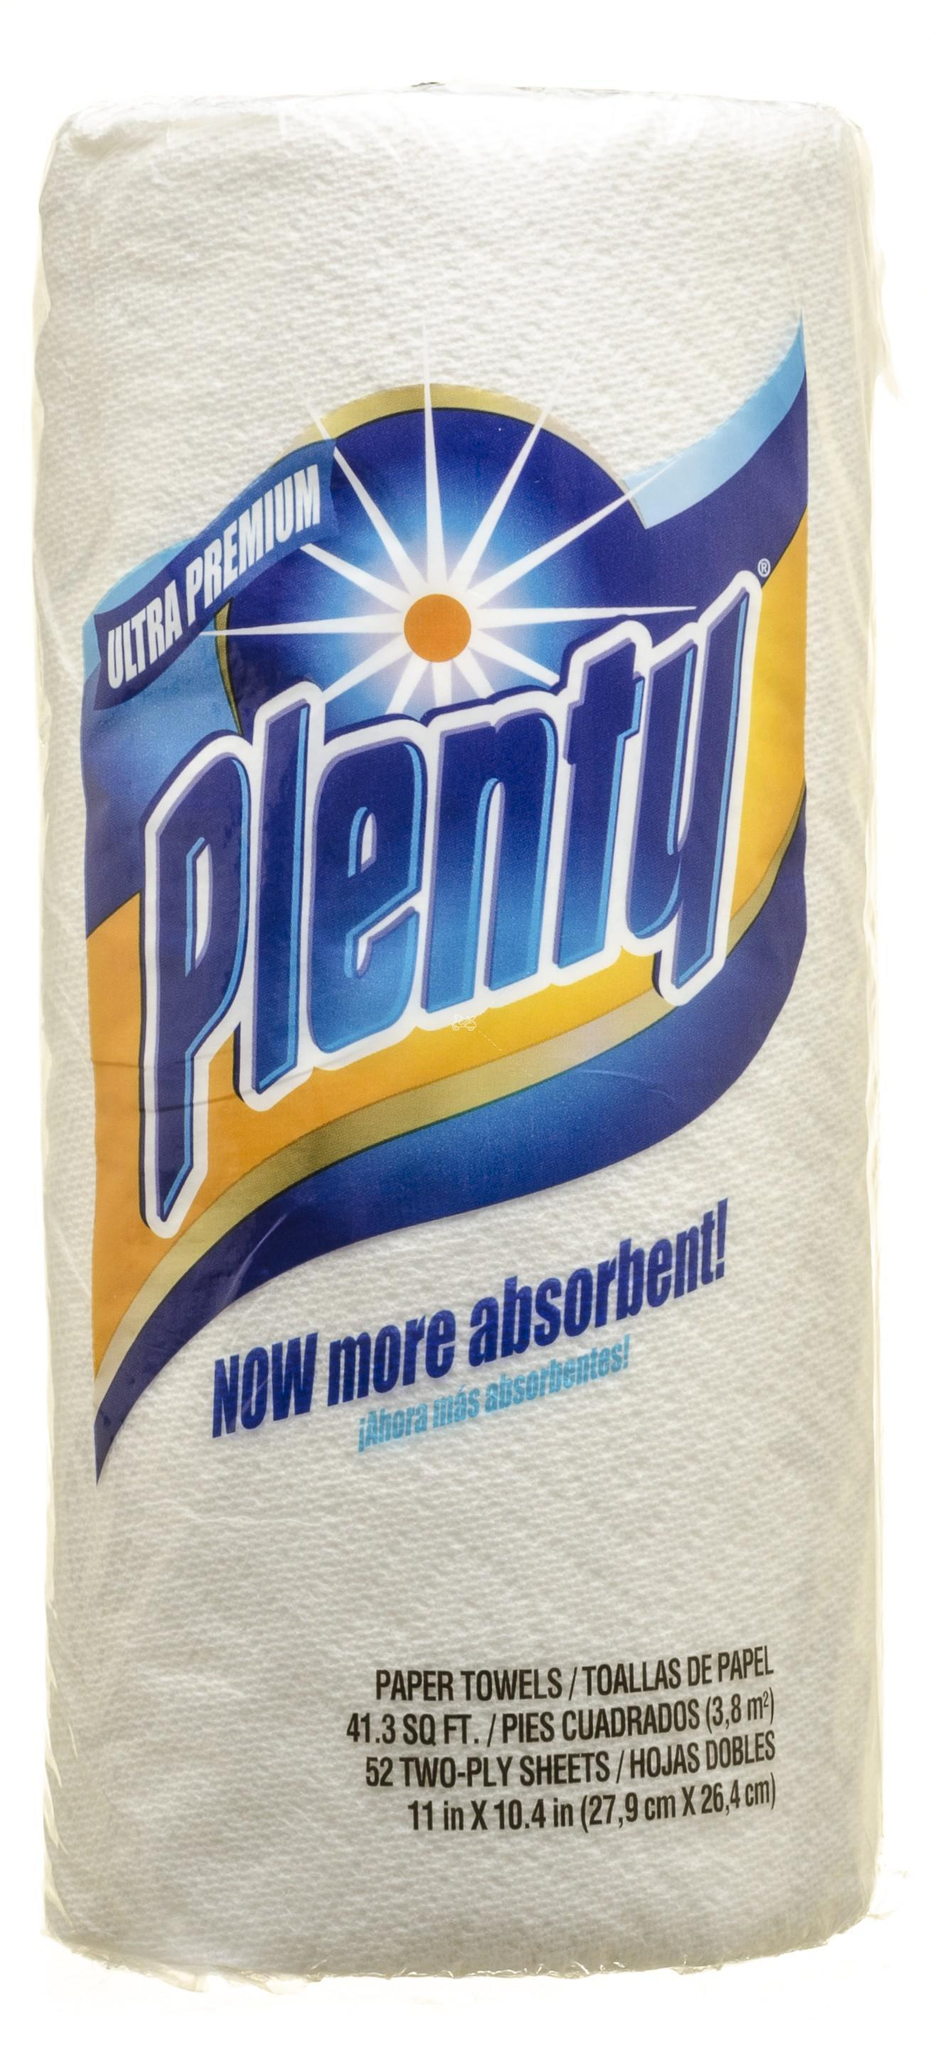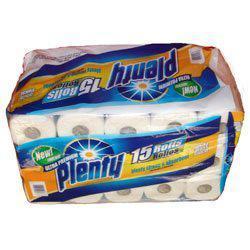The first image is the image on the left, the second image is the image on the right. Evaluate the accuracy of this statement regarding the images: "One image shows at least one six-roll multipack of paper towels.". Is it true? Answer yes or no. No. 